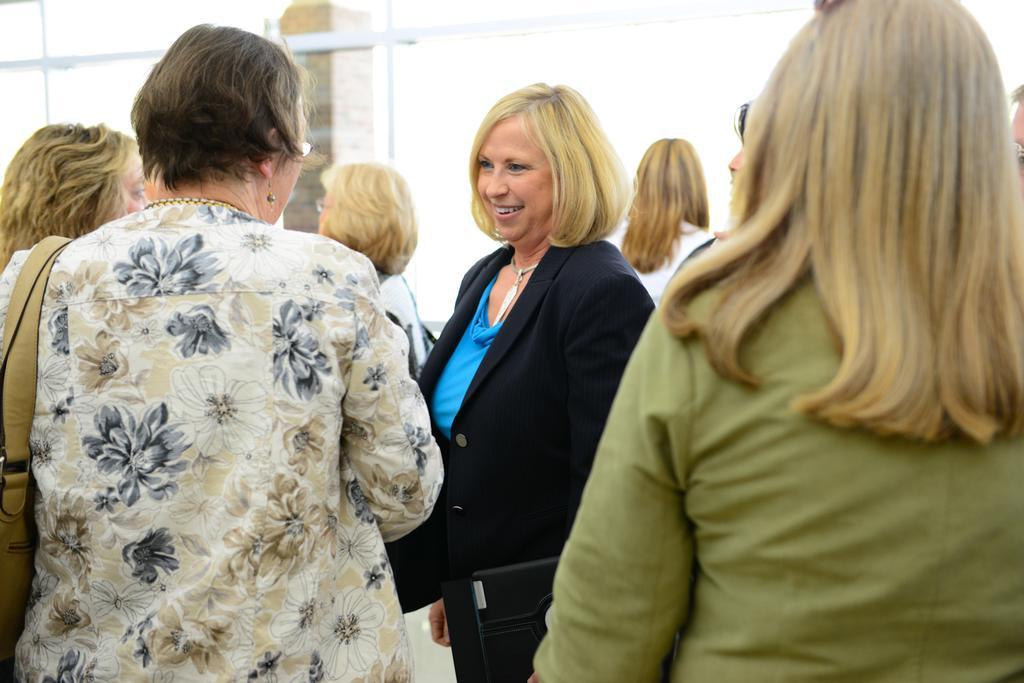Describe this image in one or two sentences. In this picture I can observe some women. There is a woman in the middle of the picture, wearing a coat. The woman is smiling. In the background I can observe a pillar. 